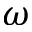Convert formula to latex. <formula><loc_0><loc_0><loc_500><loc_500>\omega</formula> 